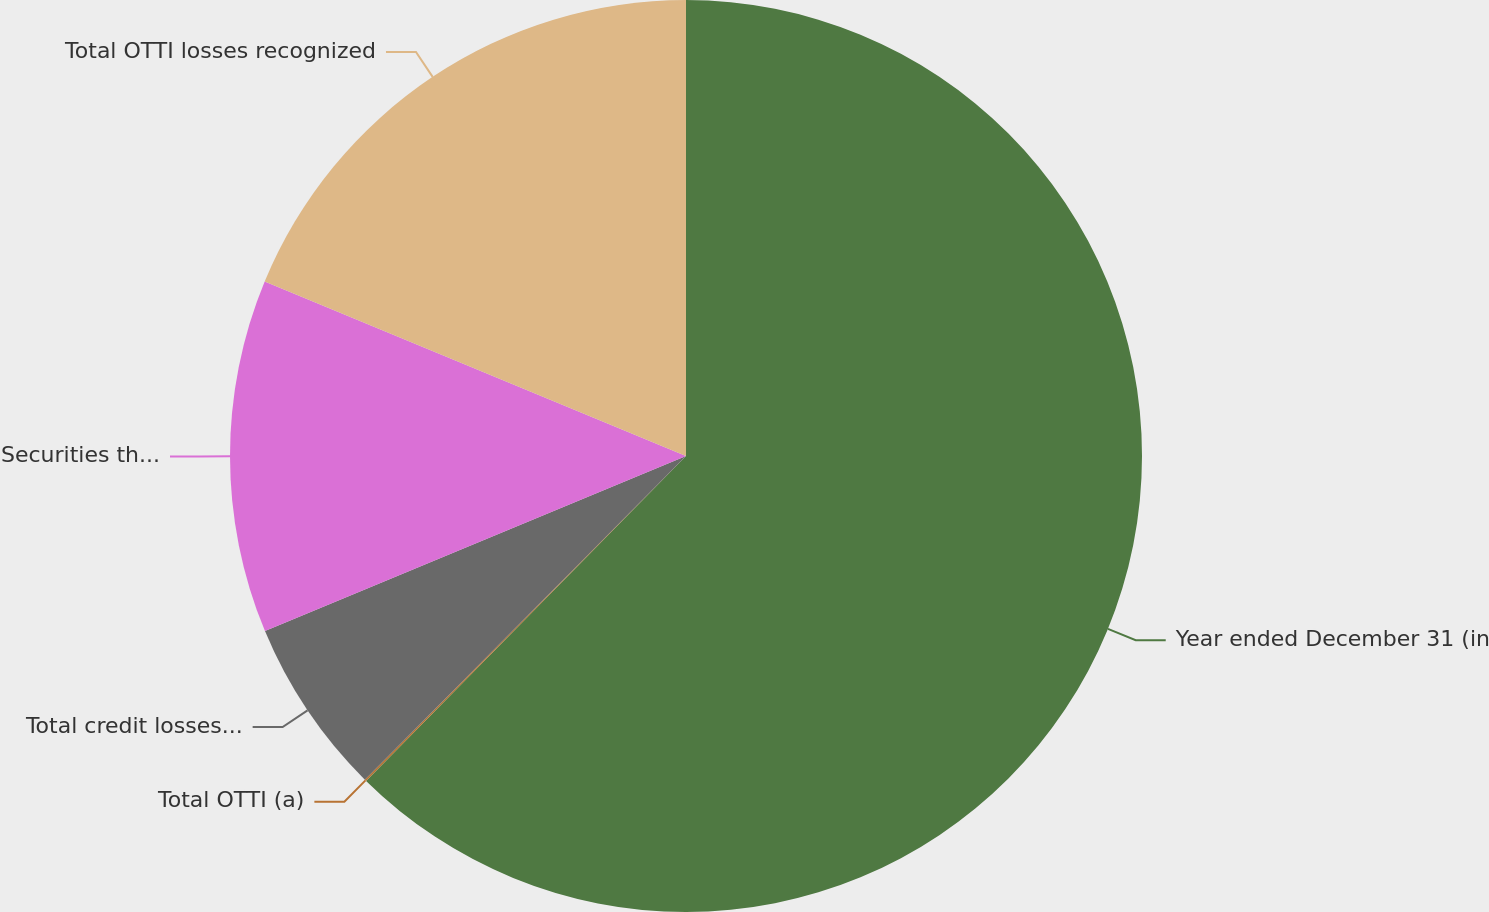Convert chart. <chart><loc_0><loc_0><loc_500><loc_500><pie_chart><fcel>Year ended December 31 (in<fcel>Total OTTI (a)<fcel>Total credit losses recognized<fcel>Securities the Firm intends to<fcel>Total OTTI losses recognized<nl><fcel>62.37%<fcel>0.06%<fcel>6.29%<fcel>12.52%<fcel>18.75%<nl></chart> 